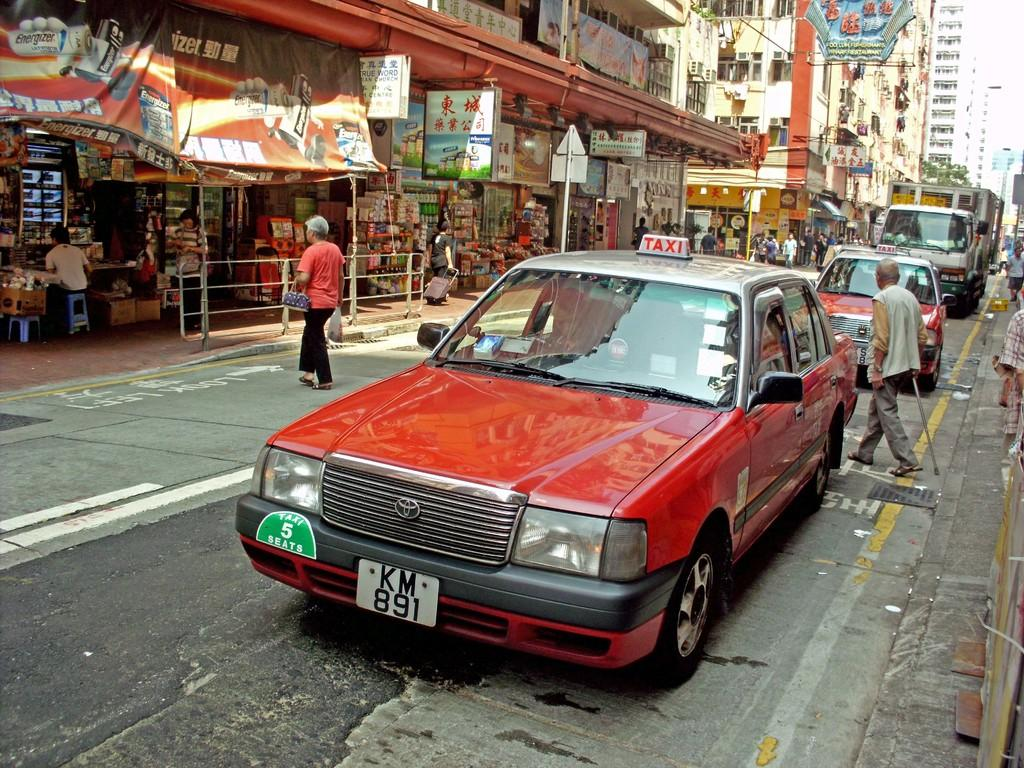Provide a one-sentence caption for the provided image. A red taxi on a narrow street with license plate KM 891. 